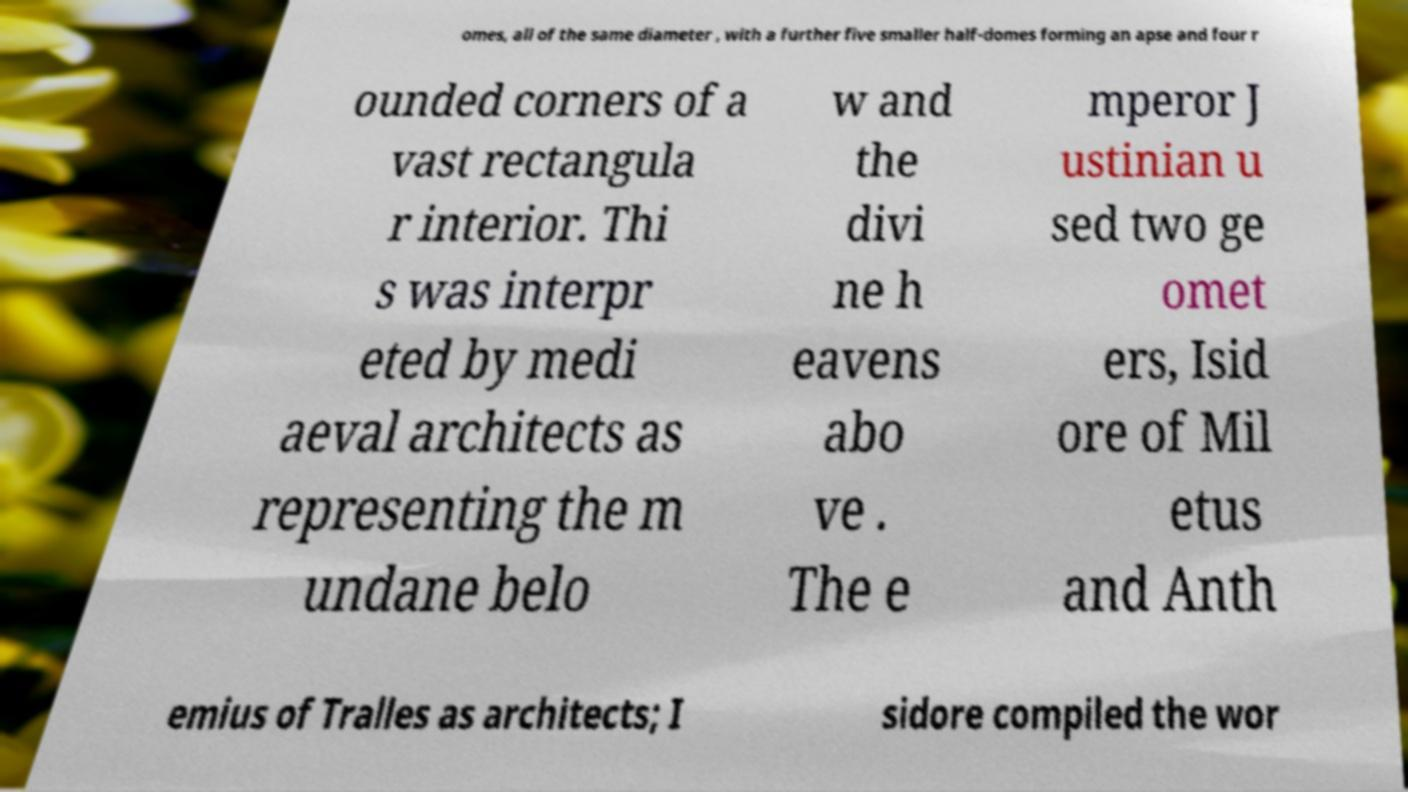What messages or text are displayed in this image? I need them in a readable, typed format. omes, all of the same diameter , with a further five smaller half-domes forming an apse and four r ounded corners of a vast rectangula r interior. Thi s was interpr eted by medi aeval architects as representing the m undane belo w and the divi ne h eavens abo ve . The e mperor J ustinian u sed two ge omet ers, Isid ore of Mil etus and Anth emius of Tralles as architects; I sidore compiled the wor 